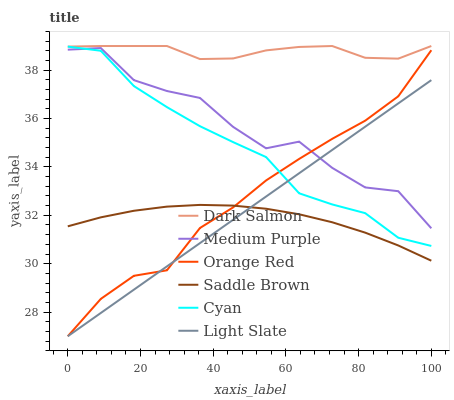Does Saddle Brown have the minimum area under the curve?
Answer yes or no. Yes. Does Dark Salmon have the maximum area under the curve?
Answer yes or no. Yes. Does Orange Red have the minimum area under the curve?
Answer yes or no. No. Does Orange Red have the maximum area under the curve?
Answer yes or no. No. Is Light Slate the smoothest?
Answer yes or no. Yes. Is Medium Purple the roughest?
Answer yes or no. Yes. Is Dark Salmon the smoothest?
Answer yes or no. No. Is Dark Salmon the roughest?
Answer yes or no. No. Does Dark Salmon have the lowest value?
Answer yes or no. No. Does Dark Salmon have the highest value?
Answer yes or no. Yes. Does Orange Red have the highest value?
Answer yes or no. No. Is Saddle Brown less than Cyan?
Answer yes or no. Yes. Is Cyan greater than Saddle Brown?
Answer yes or no. Yes. Does Cyan intersect Orange Red?
Answer yes or no. Yes. Is Cyan less than Orange Red?
Answer yes or no. No. Is Cyan greater than Orange Red?
Answer yes or no. No. Does Saddle Brown intersect Cyan?
Answer yes or no. No. 